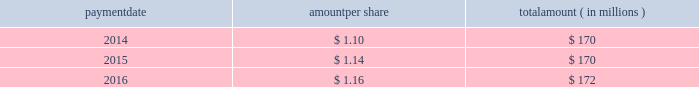Humana inc .
Notes to consolidated financial statements 2014 ( continued ) 15 .
Stockholders 2019 equity as discussed in note 2 , we elected to early adopt new guidance related to accounting for employee share-based payments prospectively effective january 1 , 2016 .
The adoption of this new guidance resulted in the recognition of approximately $ 20 million of tax benefits in net income in our consolidated statement of income for the three months ended march 31 , 2016 that had previously been recorded as additional paid-in capital in our consolidated balance sheet .
Dividends the table provides details of dividend payments , excluding dividend equivalent rights , in 2014 , 2015 , and 2016 under our board approved quarterly cash dividend policy : payment amount per share amount ( in millions ) .
Under the terms of the merger agreement , we agreed with aetna that our quarterly dividend would not exceed $ 0.29 per share prior to the closing or termination of the merger .
On october 26 , 2016 , the board declared a cash dividend of $ 0.29 per share that was paid on january 27 , 2017 to stockholders of record on january 12 , 2017 , for an aggregate amount of $ 43 million .
On february 14 , 2017 , following the termination of the merger agreement , the board declared a cash dividend of $ 0.40 per share , to be paid on april 28 , 2017 , to the stockholders of record on march 31 , 2017 .
Declaration and payment of future quarterly dividends is at the discretion of our board and may be adjusted as business needs or market conditions change .
Stock repurchases in september 2014 , our board of directors replaced a previous share repurchase authorization of up to $ 1 billion ( of which $ 816 million remained unused ) with an authorization for repurchases of up to $ 2 billion of our common shares exclusive of shares repurchased in connection with employee stock plans , which expired on december 31 , 2016 .
Under the share repurchase authorization , shares may have been purchased from time to time at prevailing prices in the open market , by block purchases , through plans designed to comply with rule 10b5-1 under the securities exchange act of 1934 , as amended , or in privately-negotiated transactions ( including pursuant to accelerated share repurchase agreements with investment banks ) , subject to certain regulatory restrictions on volume , pricing , and timing .
Pursuant to the merger agreement , after july 2 , 2015 , we were prohibited from repurchasing any of our outstanding securities without the prior written consent of aetna , other than repurchases of shares of our common stock in connection with the exercise of outstanding stock options or the vesting or settlement of outstanding restricted stock awards .
Accordingly , as announced on july 3 , 2015 , we suspended our share repurchase program. .
In 2014 what was the number of shares issued a dividend in millions? 
Computations: (170 / 1.10)
Answer: 154.54545. 